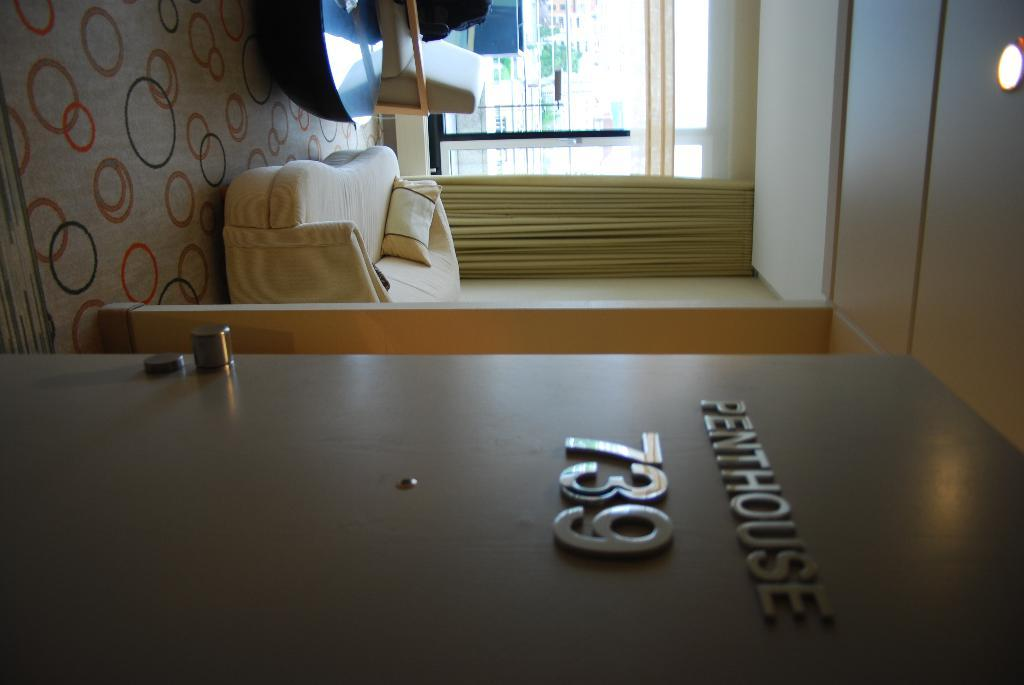What type of furniture is present in the image? There is a couch in the image. What color is the pillow on the couch? The pillow on the couch is yellow-colored. What can be seen on the wall in the image? There is a board in the image. What type of wall is visible in the image? There is a glass wall in the image. What type of window treatment is present in the image? There is a yellow-colored curtain in the image. What type of furniture is present besides the couch? There is a table in the image. How does the couch smile in the image? The couch does not have the ability to smile, as it is an inanimate object. 